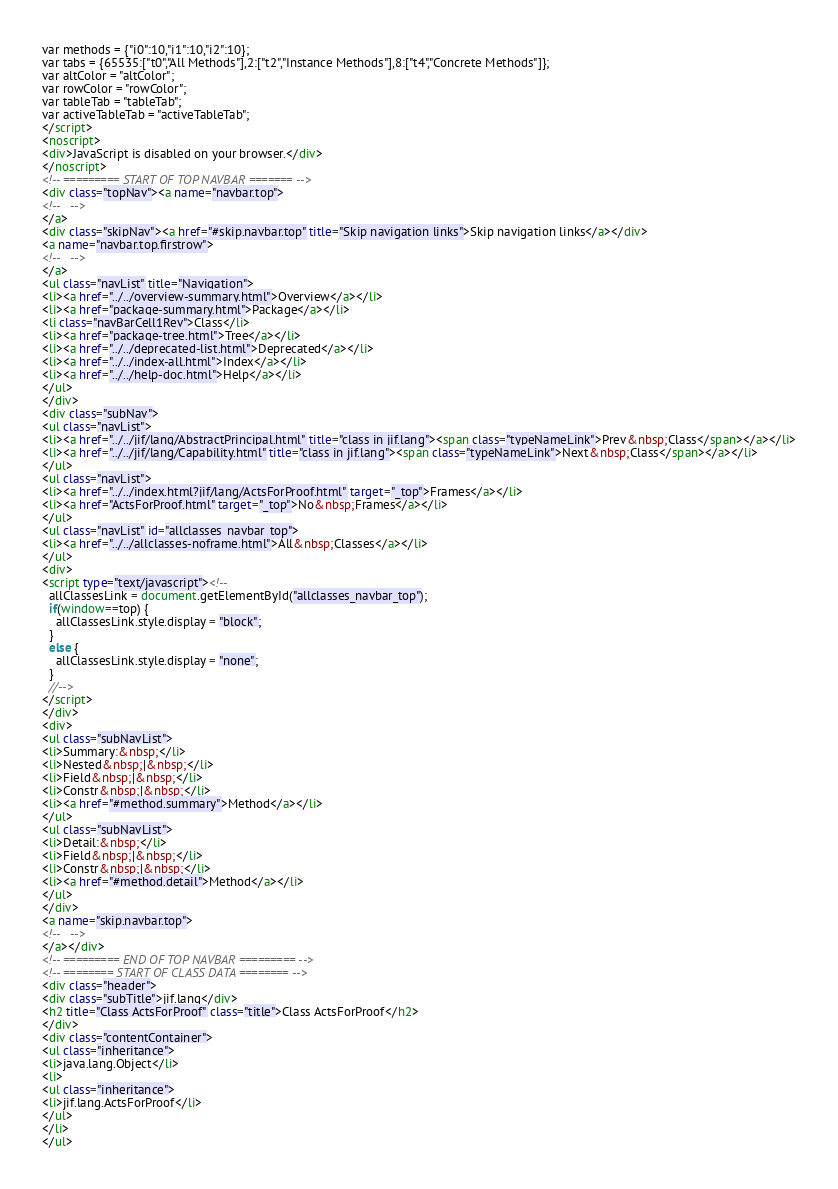<code> <loc_0><loc_0><loc_500><loc_500><_HTML_>var methods = {"i0":10,"i1":10,"i2":10};
var tabs = {65535:["t0","All Methods"],2:["t2","Instance Methods"],8:["t4","Concrete Methods"]};
var altColor = "altColor";
var rowColor = "rowColor";
var tableTab = "tableTab";
var activeTableTab = "activeTableTab";
</script>
<noscript>
<div>JavaScript is disabled on your browser.</div>
</noscript>
<!-- ========= START OF TOP NAVBAR ======= -->
<div class="topNav"><a name="navbar.top">
<!--   -->
</a>
<div class="skipNav"><a href="#skip.navbar.top" title="Skip navigation links">Skip navigation links</a></div>
<a name="navbar.top.firstrow">
<!--   -->
</a>
<ul class="navList" title="Navigation">
<li><a href="../../overview-summary.html">Overview</a></li>
<li><a href="package-summary.html">Package</a></li>
<li class="navBarCell1Rev">Class</li>
<li><a href="package-tree.html">Tree</a></li>
<li><a href="../../deprecated-list.html">Deprecated</a></li>
<li><a href="../../index-all.html">Index</a></li>
<li><a href="../../help-doc.html">Help</a></li>
</ul>
</div>
<div class="subNav">
<ul class="navList">
<li><a href="../../jif/lang/AbstractPrincipal.html" title="class in jif.lang"><span class="typeNameLink">Prev&nbsp;Class</span></a></li>
<li><a href="../../jif/lang/Capability.html" title="class in jif.lang"><span class="typeNameLink">Next&nbsp;Class</span></a></li>
</ul>
<ul class="navList">
<li><a href="../../index.html?jif/lang/ActsForProof.html" target="_top">Frames</a></li>
<li><a href="ActsForProof.html" target="_top">No&nbsp;Frames</a></li>
</ul>
<ul class="navList" id="allclasses_navbar_top">
<li><a href="../../allclasses-noframe.html">All&nbsp;Classes</a></li>
</ul>
<div>
<script type="text/javascript"><!--
  allClassesLink = document.getElementById("allclasses_navbar_top");
  if(window==top) {
    allClassesLink.style.display = "block";
  }
  else {
    allClassesLink.style.display = "none";
  }
  //-->
</script>
</div>
<div>
<ul class="subNavList">
<li>Summary:&nbsp;</li>
<li>Nested&nbsp;|&nbsp;</li>
<li>Field&nbsp;|&nbsp;</li>
<li>Constr&nbsp;|&nbsp;</li>
<li><a href="#method.summary">Method</a></li>
</ul>
<ul class="subNavList">
<li>Detail:&nbsp;</li>
<li>Field&nbsp;|&nbsp;</li>
<li>Constr&nbsp;|&nbsp;</li>
<li><a href="#method.detail">Method</a></li>
</ul>
</div>
<a name="skip.navbar.top">
<!--   -->
</a></div>
<!-- ========= END OF TOP NAVBAR ========= -->
<!-- ======== START OF CLASS DATA ======== -->
<div class="header">
<div class="subTitle">jif.lang</div>
<h2 title="Class ActsForProof" class="title">Class ActsForProof</h2>
</div>
<div class="contentContainer">
<ul class="inheritance">
<li>java.lang.Object</li>
<li>
<ul class="inheritance">
<li>jif.lang.ActsForProof</li>
</ul>
</li>
</ul></code> 